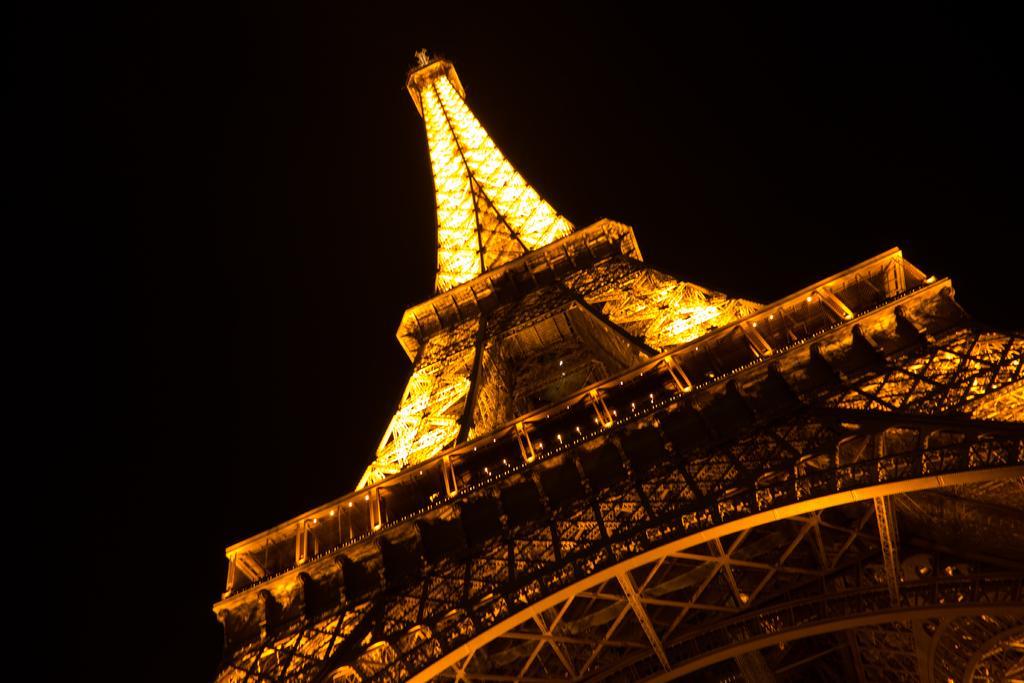In one or two sentences, can you explain what this image depicts? This picture is clicked outside. In the foreground we can see a tower and we can see the lights. In the background there is a sky. 